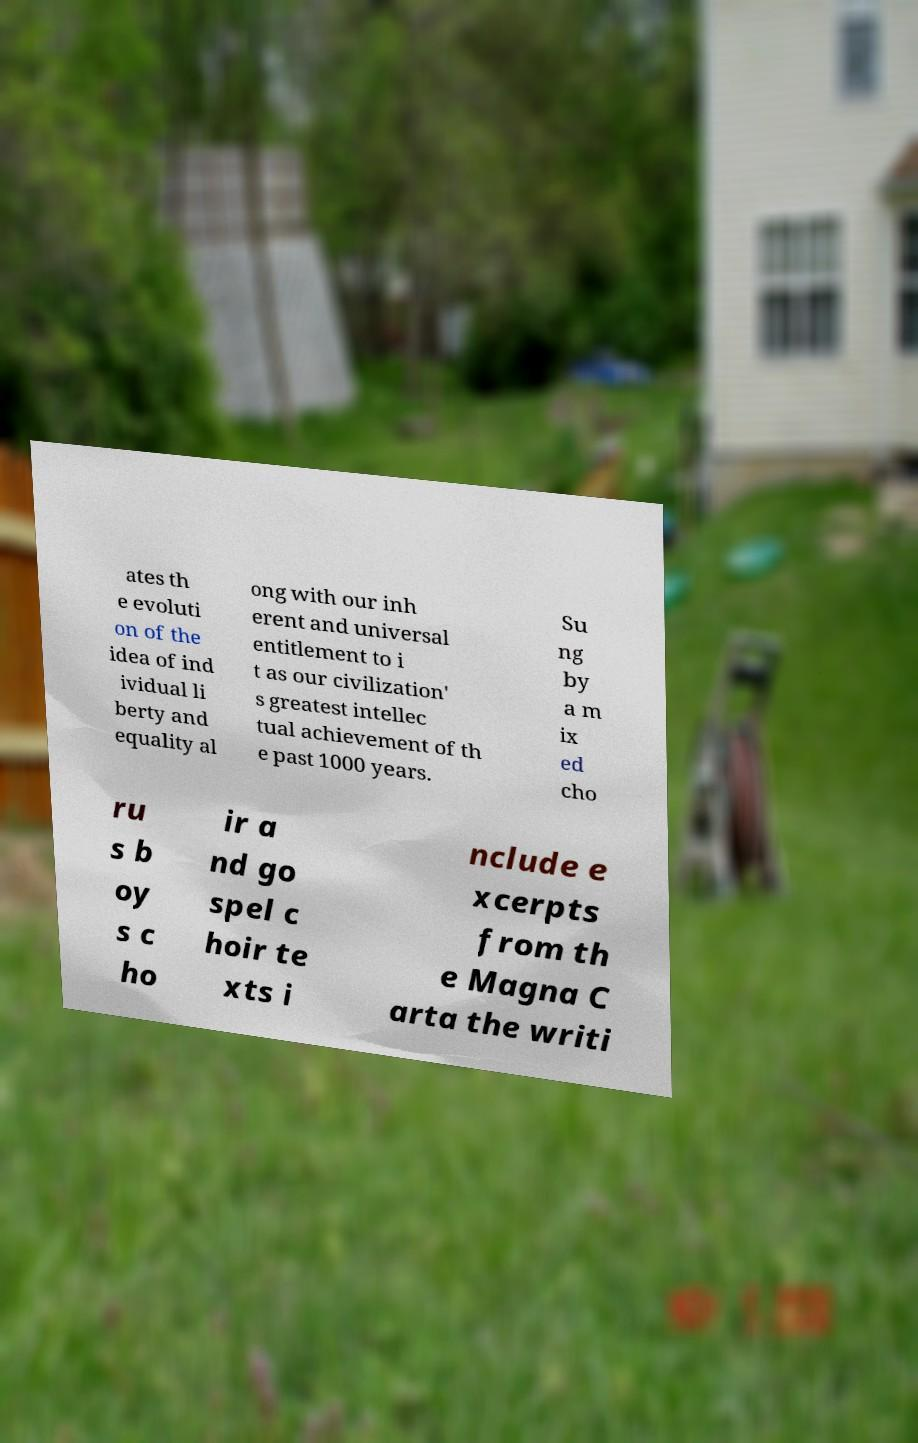I need the written content from this picture converted into text. Can you do that? ates th e evoluti on of the idea of ind ividual li berty and equality al ong with our inh erent and universal entitlement to i t as our civilization' s greatest intellec tual achievement of th e past 1000 years. Su ng by a m ix ed cho ru s b oy s c ho ir a nd go spel c hoir te xts i nclude e xcerpts from th e Magna C arta the writi 